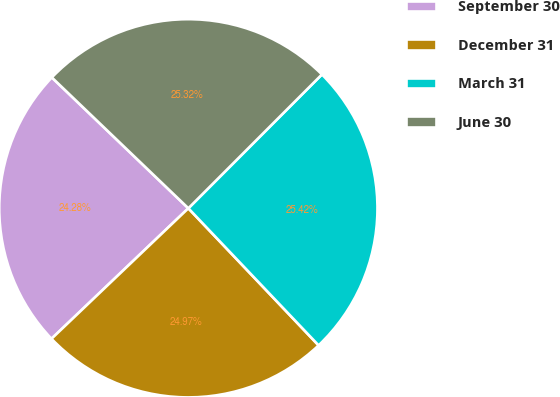Convert chart to OTSL. <chart><loc_0><loc_0><loc_500><loc_500><pie_chart><fcel>September 30<fcel>December 31<fcel>March 31<fcel>June 30<nl><fcel>24.28%<fcel>24.97%<fcel>25.42%<fcel>25.32%<nl></chart> 